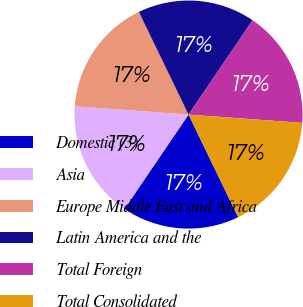Convert chart to OTSL. <chart><loc_0><loc_0><loc_500><loc_500><pie_chart><fcel>Domestic (3)<fcel>Asia<fcel>Europe Middle East and Africa<fcel>Latin America and the<fcel>Total Foreign<fcel>Total Consolidated<nl><fcel>16.66%<fcel>16.67%<fcel>16.67%<fcel>16.67%<fcel>16.67%<fcel>16.67%<nl></chart> 